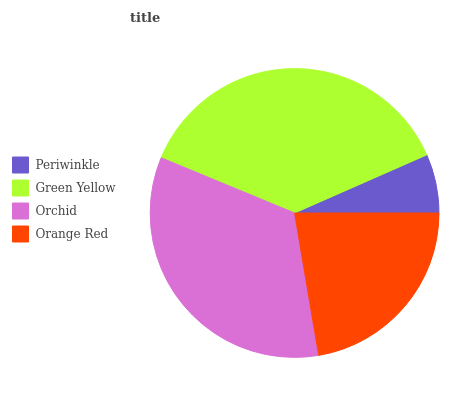Is Periwinkle the minimum?
Answer yes or no. Yes. Is Green Yellow the maximum?
Answer yes or no. Yes. Is Orchid the minimum?
Answer yes or no. No. Is Orchid the maximum?
Answer yes or no. No. Is Green Yellow greater than Orchid?
Answer yes or no. Yes. Is Orchid less than Green Yellow?
Answer yes or no. Yes. Is Orchid greater than Green Yellow?
Answer yes or no. No. Is Green Yellow less than Orchid?
Answer yes or no. No. Is Orchid the high median?
Answer yes or no. Yes. Is Orange Red the low median?
Answer yes or no. Yes. Is Orange Red the high median?
Answer yes or no. No. Is Periwinkle the low median?
Answer yes or no. No. 